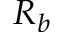<formula> <loc_0><loc_0><loc_500><loc_500>R _ { b }</formula> 